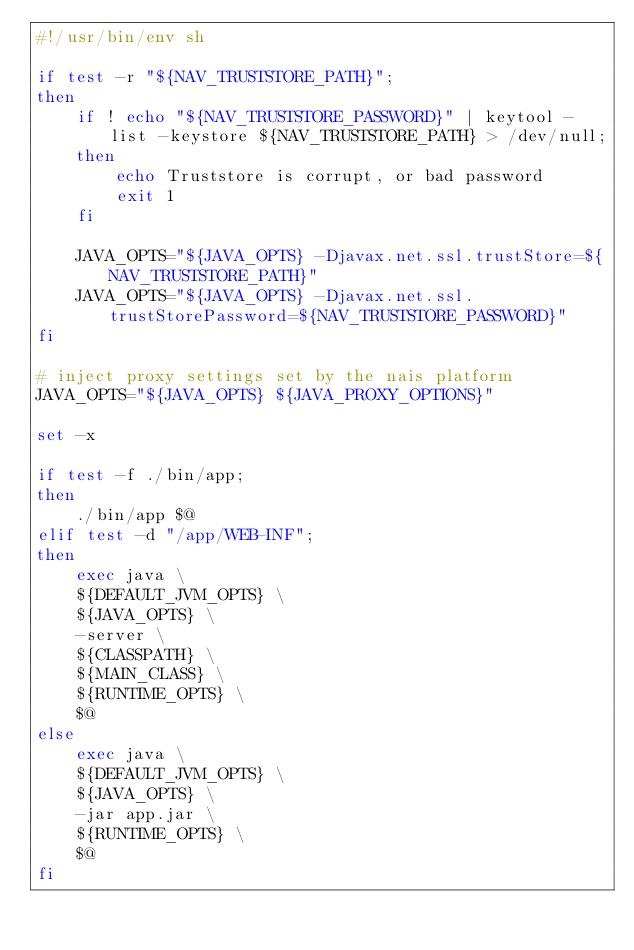Convert code to text. <code><loc_0><loc_0><loc_500><loc_500><_Bash_>#!/usr/bin/env sh

if test -r "${NAV_TRUSTSTORE_PATH}";
then
    if ! echo "${NAV_TRUSTSTORE_PASSWORD}" | keytool -list -keystore ${NAV_TRUSTSTORE_PATH} > /dev/null;
    then
        echo Truststore is corrupt, or bad password
        exit 1
    fi

    JAVA_OPTS="${JAVA_OPTS} -Djavax.net.ssl.trustStore=${NAV_TRUSTSTORE_PATH}"
    JAVA_OPTS="${JAVA_OPTS} -Djavax.net.ssl.trustStorePassword=${NAV_TRUSTSTORE_PASSWORD}"
fi

# inject proxy settings set by the nais platform
JAVA_OPTS="${JAVA_OPTS} ${JAVA_PROXY_OPTIONS}"

set -x

if test -f ./bin/app;
then
    ./bin/app $@
elif test -d "/app/WEB-INF";
then
    exec java \
    ${DEFAULT_JVM_OPTS} \
    ${JAVA_OPTS} \
    -server \
    ${CLASSPATH} \
    ${MAIN_CLASS} \
    ${RUNTIME_OPTS} \
    $@
else
    exec java \
    ${DEFAULT_JVM_OPTS} \
    ${JAVA_OPTS} \
    -jar app.jar \
    ${RUNTIME_OPTS} \
    $@
fi
</code> 